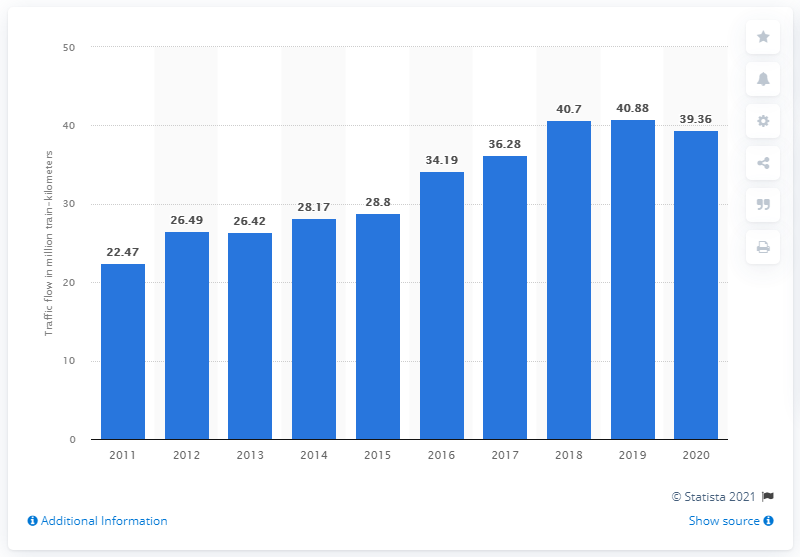Highlight a few significant elements in this photo. In 2020, MRT trains in Singapore traveled a total of 39,360 km. 